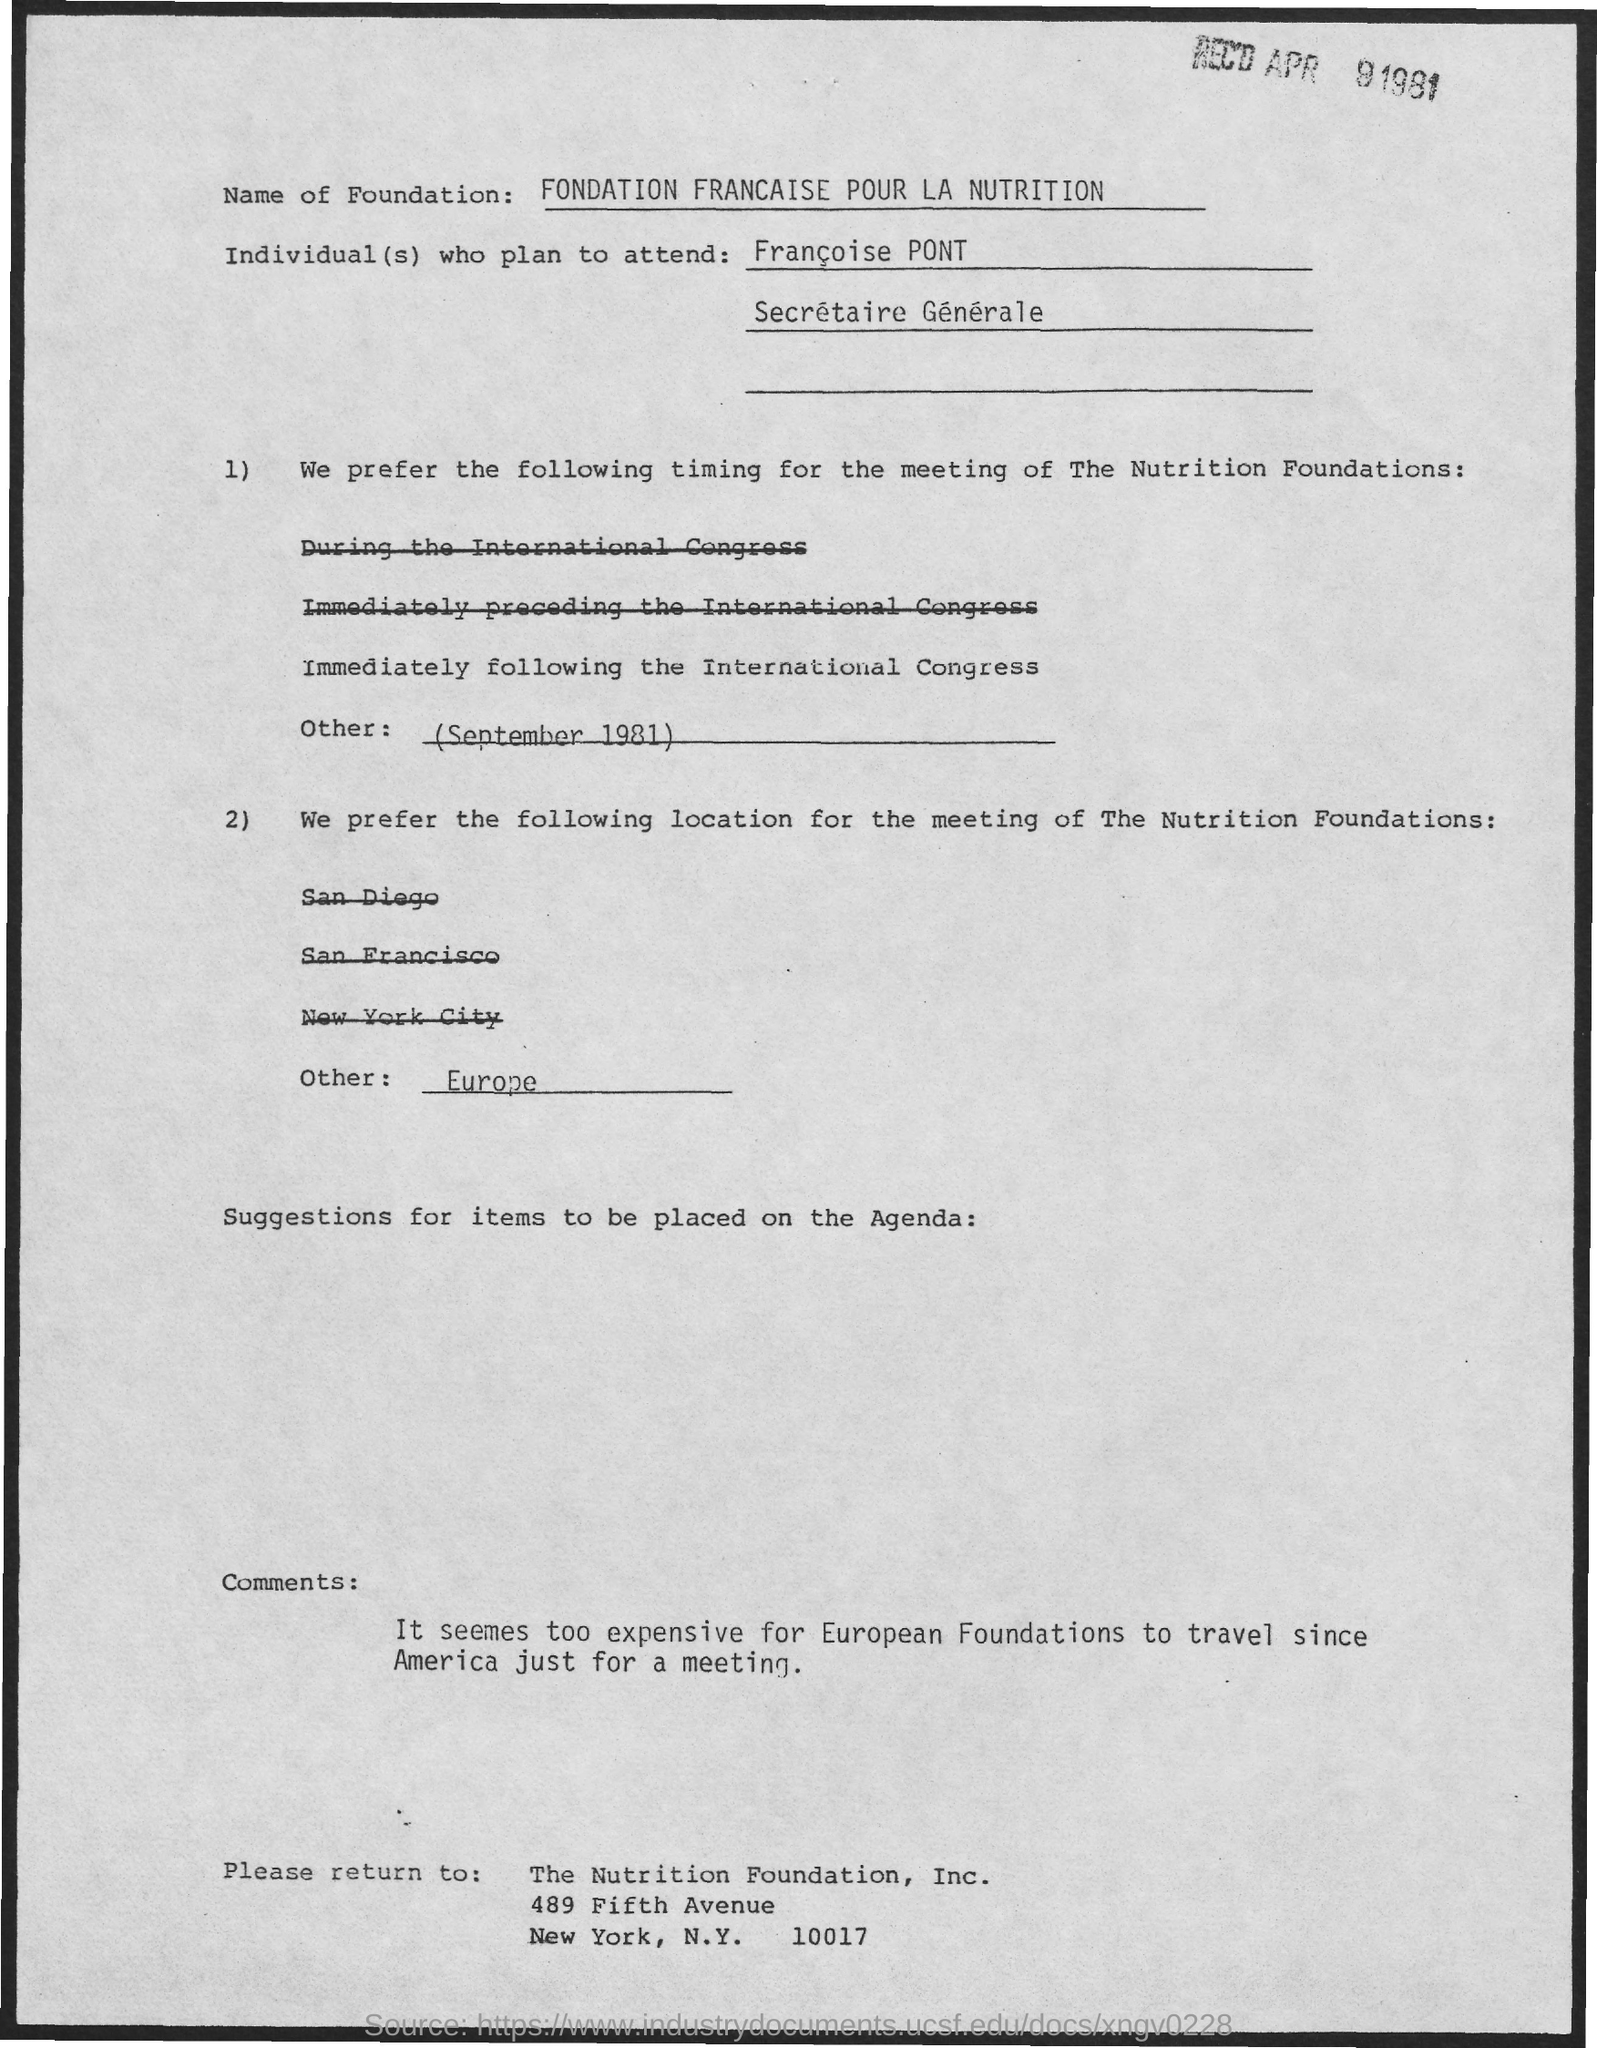Specify some key components in this picture. The preferred location for the meeting of The Nutrition Foundations is Europe. 